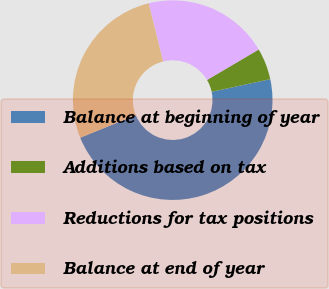Convert chart to OTSL. <chart><loc_0><loc_0><loc_500><loc_500><pie_chart><fcel>Balance at beginning of year<fcel>Additions based on tax<fcel>Reductions for tax positions<fcel>Balance at end of year<nl><fcel>47.23%<fcel>5.1%<fcel>20.4%<fcel>27.27%<nl></chart> 